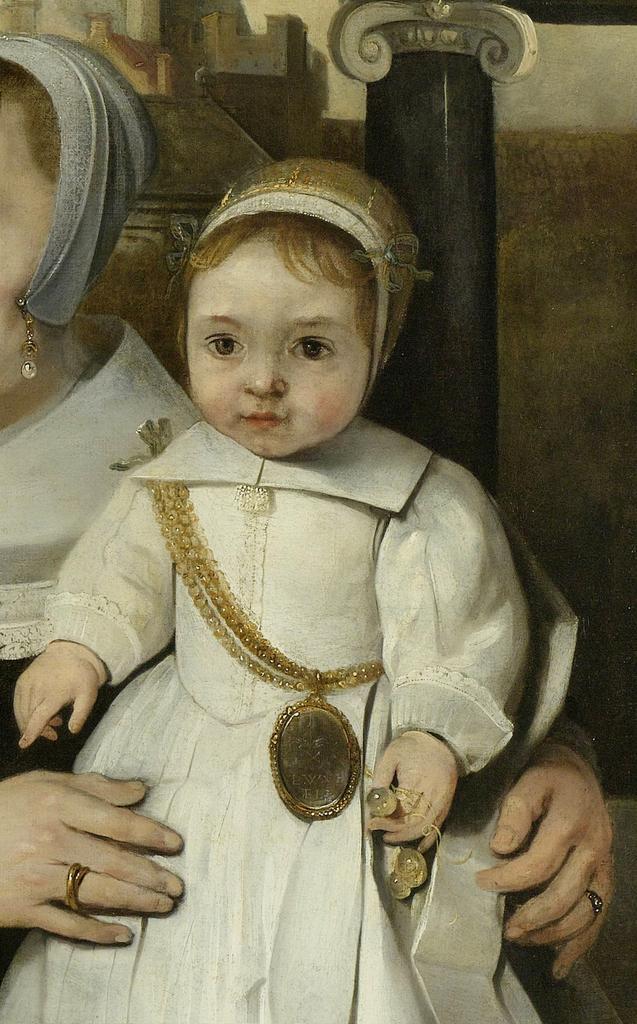Could you give a brief overview of what you see in this image? In this image we can see painting of a person, kid, chain, pillar, and wall. 